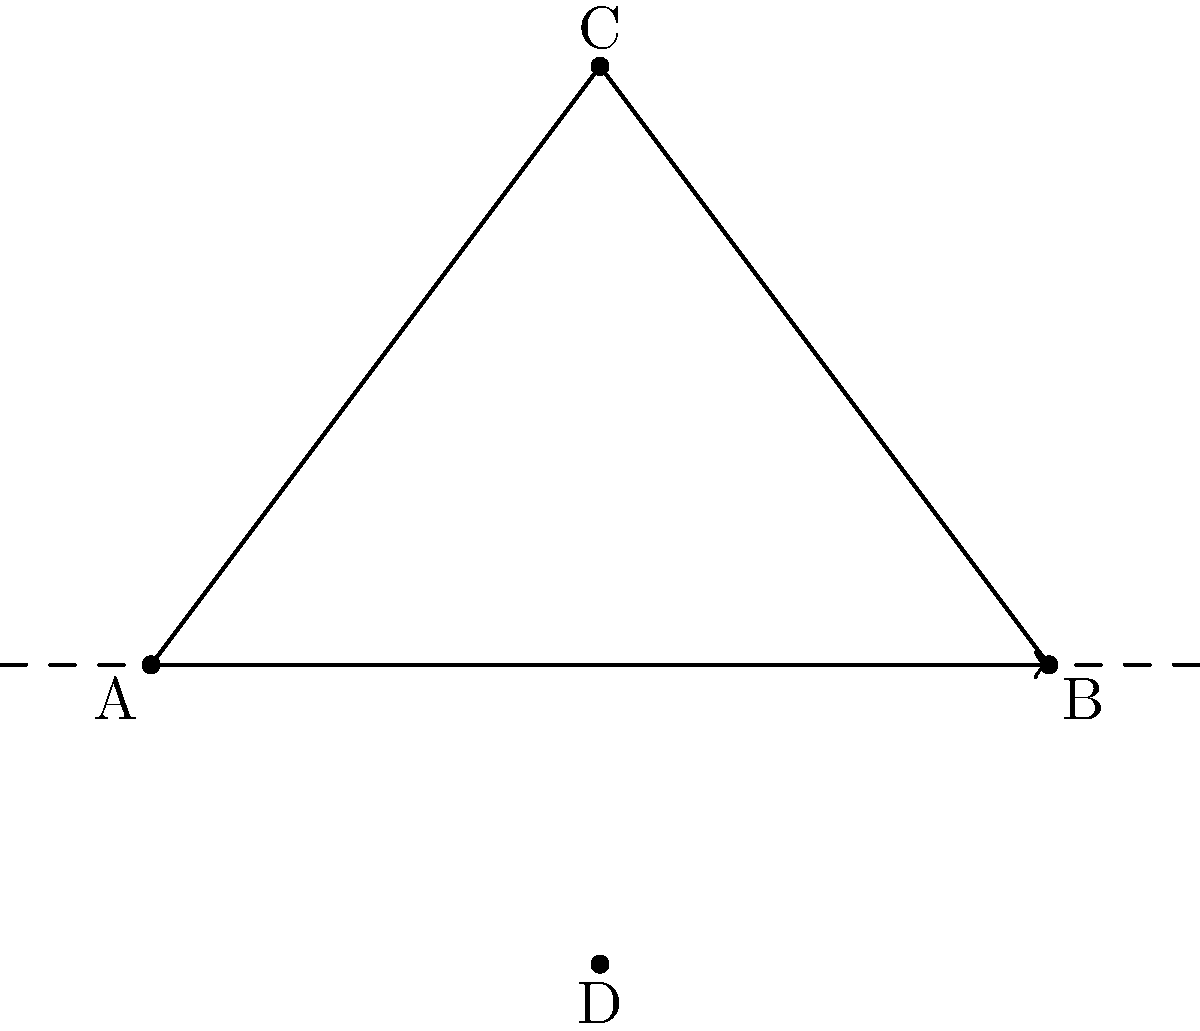In the My Hero Academia universe, Aizawa-sensei is teaching the students about reflection in geometry using character silhouettes. The triangle ABC represents All Might's iconic hair silhouette. If this silhouette is reflected across the x-axis, what are the coordinates of point C' (the reflection of point C)? To find the coordinates of C' after reflecting triangle ABC across the x-axis, we follow these steps:

1. Identify the original coordinates of point C: (3, 4)

2. Understand the reflection rule across the x-axis:
   - The x-coordinate remains the same
   - The y-coordinate changes sign (positive becomes negative and vice versa)

3. Apply the reflection rule to point C:
   - x-coordinate of C': 3 (unchanged)
   - y-coordinate of C': -4 (sign changed from positive to negative)

4. Combine the new coordinates:
   C' = (3, -4)

Therefore, after reflection, the coordinates of point C' are (3, -4).
Answer: (3, -4) 